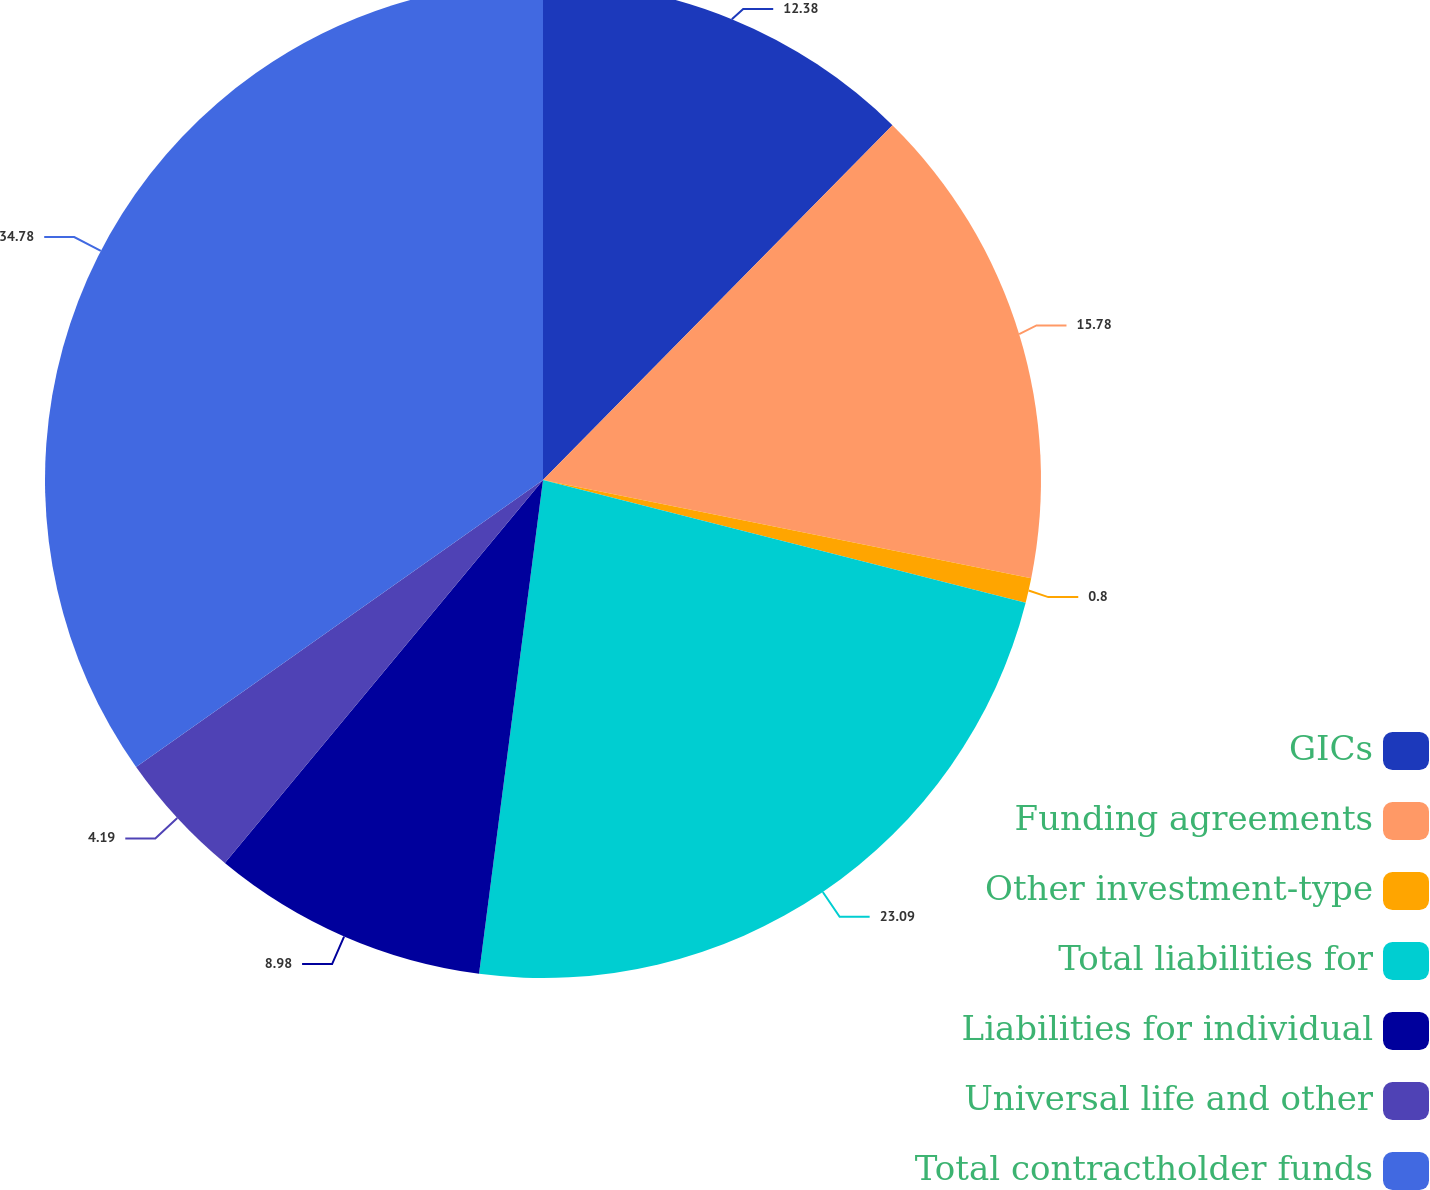Convert chart. <chart><loc_0><loc_0><loc_500><loc_500><pie_chart><fcel>GICs<fcel>Funding agreements<fcel>Other investment-type<fcel>Total liabilities for<fcel>Liabilities for individual<fcel>Universal life and other<fcel>Total contractholder funds<nl><fcel>12.38%<fcel>15.78%<fcel>0.8%<fcel>23.09%<fcel>8.98%<fcel>4.19%<fcel>34.78%<nl></chart> 